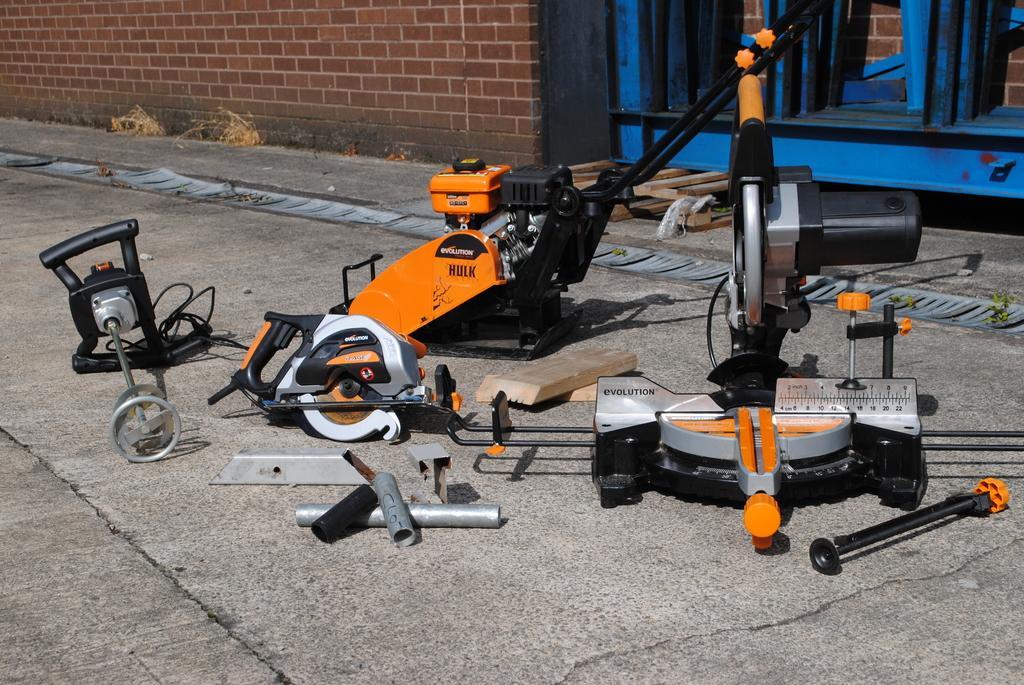Could you give a brief overview of what you see in this image? In this picture I can observe machinery placed on the land. This machinery is in orange and black color. In the background I can observe wall. 